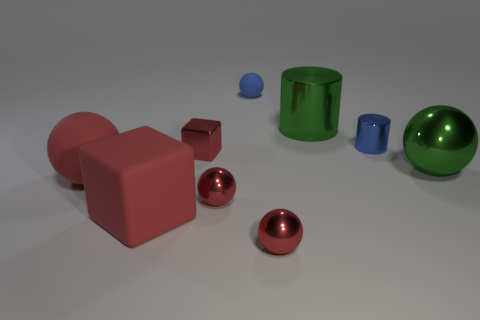What could be the possible use for the different shapes in the image if they were actual objects? If these shapes were actual objects, they could serve various functions depending on their size and material. For example, the spheres could be decorative elements or part of a children's play set, while the cubes and cylinders might be building blocks or containers. Are there any patterns or uniformity in how the objects are arranged? The objects do not show a clear pattern or uniform arrangement; they seem to be placed randomly across the surface. This scattered placement draws attention to the individual characteristics of each object rather than creating a sense of order or design. 